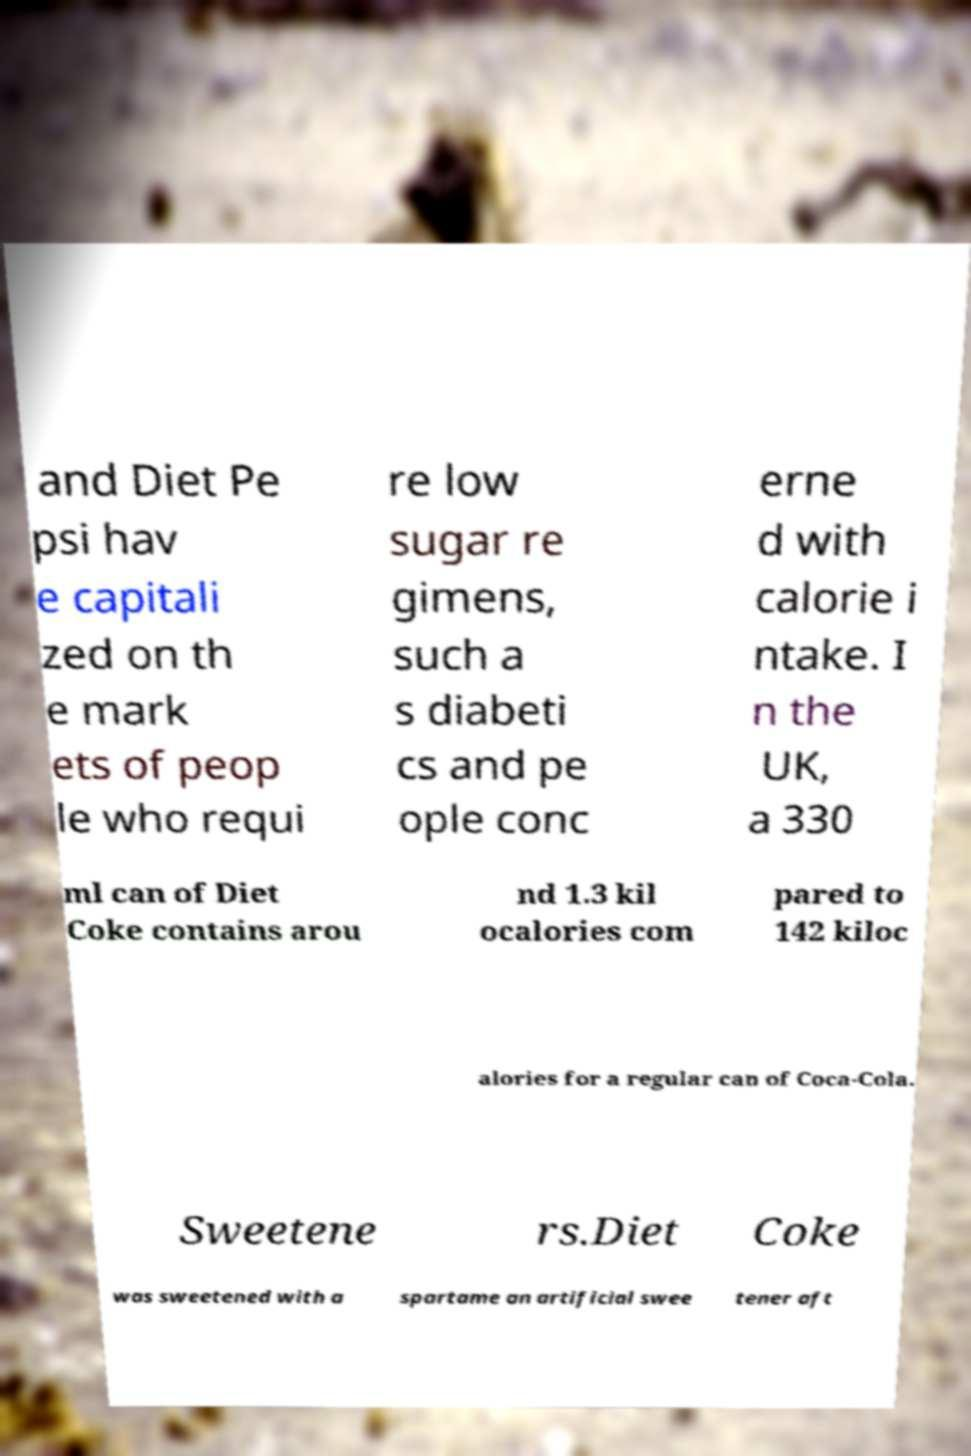Could you assist in decoding the text presented in this image and type it out clearly? and Diet Pe psi hav e capitali zed on th e mark ets of peop le who requi re low sugar re gimens, such a s diabeti cs and pe ople conc erne d with calorie i ntake. I n the UK, a 330 ml can of Diet Coke contains arou nd 1.3 kil ocalories com pared to 142 kiloc alories for a regular can of Coca-Cola. Sweetene rs.Diet Coke was sweetened with a spartame an artificial swee tener aft 